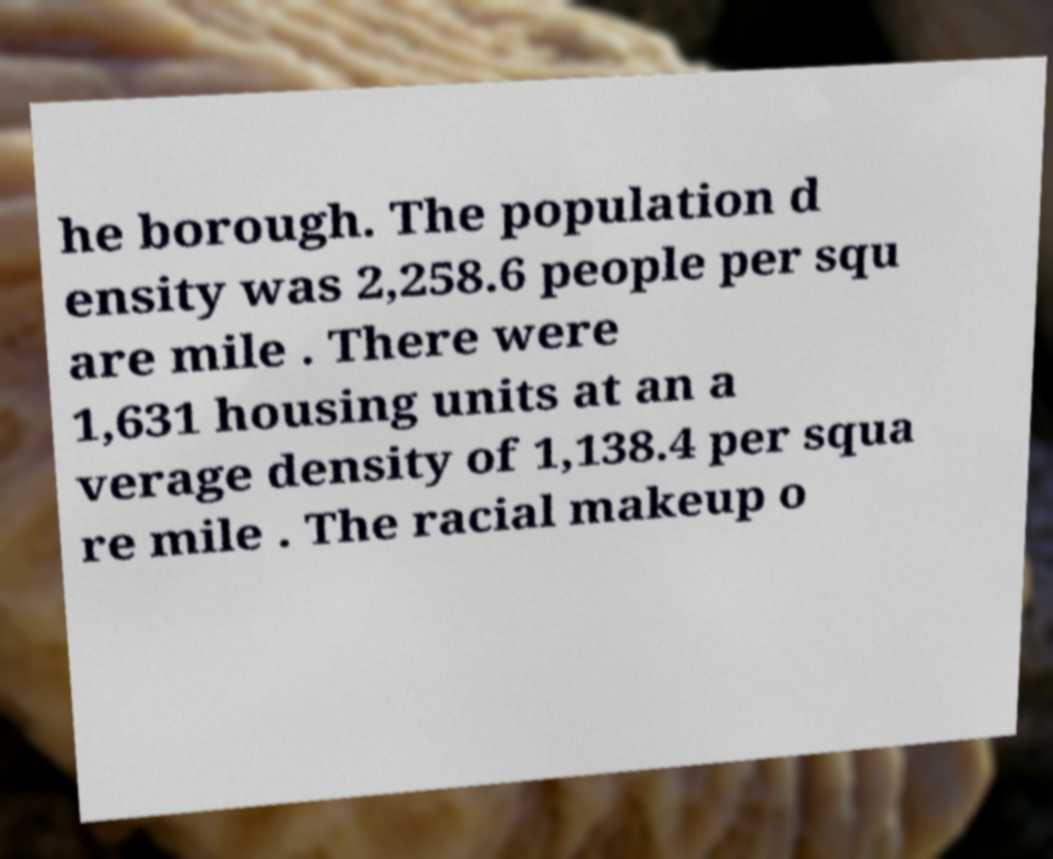Could you extract and type out the text from this image? he borough. The population d ensity was 2,258.6 people per squ are mile . There were 1,631 housing units at an a verage density of 1,138.4 per squa re mile . The racial makeup o 